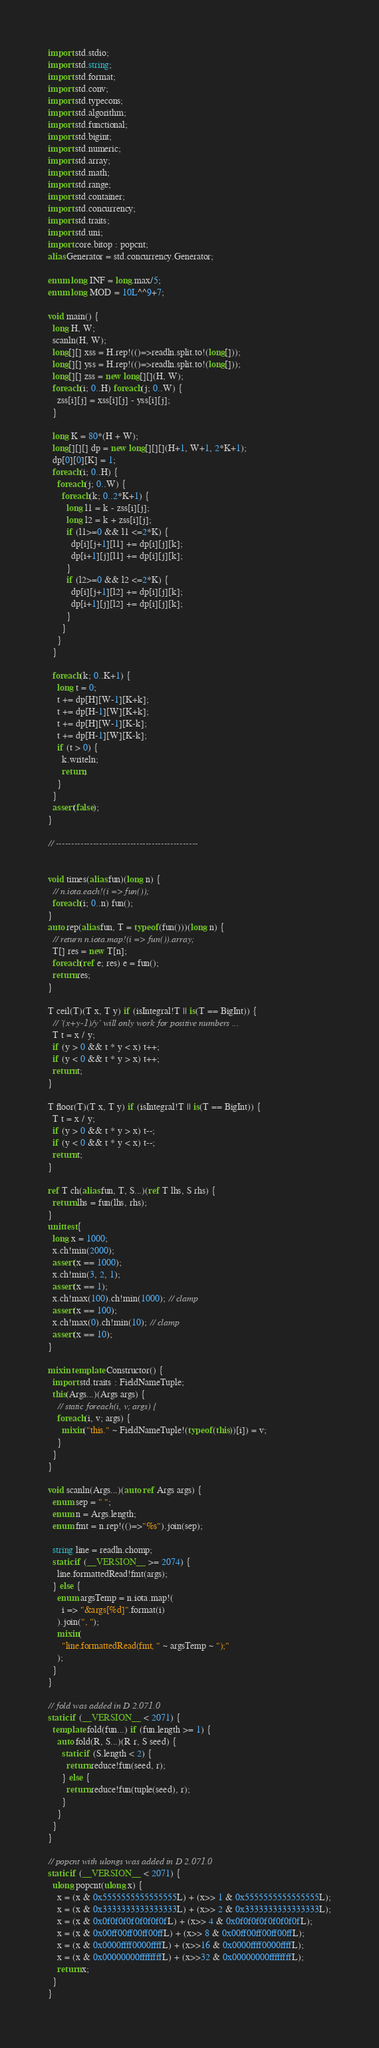Convert code to text. <code><loc_0><loc_0><loc_500><loc_500><_D_>import std.stdio;
import std.string;
import std.format;
import std.conv;
import std.typecons;
import std.algorithm;
import std.functional;
import std.bigint;
import std.numeric;
import std.array;
import std.math;
import std.range;
import std.container;
import std.concurrency;
import std.traits;
import std.uni;
import core.bitop : popcnt;
alias Generator = std.concurrency.Generator;

enum long INF = long.max/5;
enum long MOD = 10L^^9+7;

void main() {
  long H, W;
  scanln(H, W);
  long[][] xss = H.rep!(()=>readln.split.to!(long[]));
  long[][] yss = H.rep!(()=>readln.split.to!(long[]));
  long[][] zss = new long[][](H, W);
  foreach(i; 0..H) foreach(j; 0..W) {
    zss[i][j] = xss[i][j] - yss[i][j];
  }

  long K = 80*(H + W);
  long[][][] dp = new long[][][](H+1, W+1, 2*K+1);
  dp[0][0][K] = 1;
  foreach(i; 0..H) {
    foreach(j; 0..W) {
      foreach(k; 0..2*K+1) {
        long l1 = k - zss[i][j];
        long l2 = k + zss[i][j];
        if (l1>=0 && l1 <=2*K) {
          dp[i][j+1][l1] += dp[i][j][k];
          dp[i+1][j][l1] += dp[i][j][k];
        }
        if (l2>=0 && l2 <=2*K) {
          dp[i][j+1][l2] += dp[i][j][k];
          dp[i+1][j][l2] += dp[i][j][k];
        }
      }
    }
  }

  foreach(k; 0..K+1) {
    long t = 0;
    t += dp[H][W-1][K+k];
    t += dp[H-1][W][K+k];
    t += dp[H][W-1][K-k];
    t += dp[H-1][W][K-k];
    if (t > 0) {
      k.writeln;
      return;
    }
  }
  assert(false);
}

// ----------------------------------------------


void times(alias fun)(long n) {
  // n.iota.each!(i => fun());
  foreach(i; 0..n) fun();
}
auto rep(alias fun, T = typeof(fun()))(long n) {
  // return n.iota.map!(i => fun()).array;
  T[] res = new T[n];
  foreach(ref e; res) e = fun();
  return res;
}

T ceil(T)(T x, T y) if (isIntegral!T || is(T == BigInt)) {
  // `(x+y-1)/y` will only work for positive numbers ...
  T t = x / y;
  if (y > 0 && t * y < x) t++;
  if (y < 0 && t * y > x) t++;
  return t;
}

T floor(T)(T x, T y) if (isIntegral!T || is(T == BigInt)) {
  T t = x / y;
  if (y > 0 && t * y > x) t--;
  if (y < 0 && t * y < x) t--;
  return t;
}

ref T ch(alias fun, T, S...)(ref T lhs, S rhs) {
  return lhs = fun(lhs, rhs);
}
unittest {
  long x = 1000;
  x.ch!min(2000);
  assert(x == 1000);
  x.ch!min(3, 2, 1);
  assert(x == 1);
  x.ch!max(100).ch!min(1000); // clamp
  assert(x == 100);
  x.ch!max(0).ch!min(10); // clamp
  assert(x == 10);
}

mixin template Constructor() {
  import std.traits : FieldNameTuple;
  this(Args...)(Args args) {
    // static foreach(i, v; args) {
    foreach(i, v; args) {
      mixin("this." ~ FieldNameTuple!(typeof(this))[i]) = v;
    }
  }
}

void scanln(Args...)(auto ref Args args) {
  enum sep = " ";
  enum n = Args.length;
  enum fmt = n.rep!(()=>"%s").join(sep);

  string line = readln.chomp;
  static if (__VERSION__ >= 2074) {
    line.formattedRead!fmt(args);
  } else {
    enum argsTemp = n.iota.map!(
      i => "&args[%d]".format(i)
    ).join(", ");
    mixin(
      "line.formattedRead(fmt, " ~ argsTemp ~ ");"
    );
  }
}

// fold was added in D 2.071.0
static if (__VERSION__ < 2071) {
  template fold(fun...) if (fun.length >= 1) {
    auto fold(R, S...)(R r, S seed) {
      static if (S.length < 2) {
        return reduce!fun(seed, r);
      } else {
        return reduce!fun(tuple(seed), r);
      }
    }
  }
}

// popcnt with ulongs was added in D 2.071.0
static if (__VERSION__ < 2071) {
  ulong popcnt(ulong x) {
    x = (x & 0x5555555555555555L) + (x>> 1 & 0x5555555555555555L);
    x = (x & 0x3333333333333333L) + (x>> 2 & 0x3333333333333333L);
    x = (x & 0x0f0f0f0f0f0f0f0fL) + (x>> 4 & 0x0f0f0f0f0f0f0f0fL);
    x = (x & 0x00ff00ff00ff00ffL) + (x>> 8 & 0x00ff00ff00ff00ffL);
    x = (x & 0x0000ffff0000ffffL) + (x>>16 & 0x0000ffff0000ffffL);
    x = (x & 0x00000000ffffffffL) + (x>>32 & 0x00000000ffffffffL);
    return x;
  }
}
</code> 